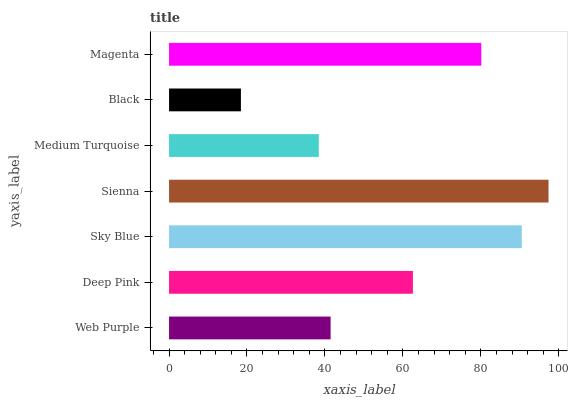Is Black the minimum?
Answer yes or no. Yes. Is Sienna the maximum?
Answer yes or no. Yes. Is Deep Pink the minimum?
Answer yes or no. No. Is Deep Pink the maximum?
Answer yes or no. No. Is Deep Pink greater than Web Purple?
Answer yes or no. Yes. Is Web Purple less than Deep Pink?
Answer yes or no. Yes. Is Web Purple greater than Deep Pink?
Answer yes or no. No. Is Deep Pink less than Web Purple?
Answer yes or no. No. Is Deep Pink the high median?
Answer yes or no. Yes. Is Deep Pink the low median?
Answer yes or no. Yes. Is Web Purple the high median?
Answer yes or no. No. Is Black the low median?
Answer yes or no. No. 